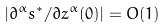Convert formula to latex. <formula><loc_0><loc_0><loc_500><loc_500>| \partial ^ { \alpha } s ^ { \ast } / \partial z ^ { \alpha } ( 0 ) | = O ( 1 )</formula> 